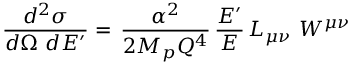<formula> <loc_0><loc_0><loc_500><loc_500>\frac { d ^ { 2 } \sigma } { d \Omega d E ^ { \prime } } = \, \frac { \alpha ^ { 2 } } { 2 M _ { p } Q ^ { 4 } } \, \frac { E ^ { \prime } } { E } \, L _ { \mu \nu } W ^ { \mu \nu }</formula> 